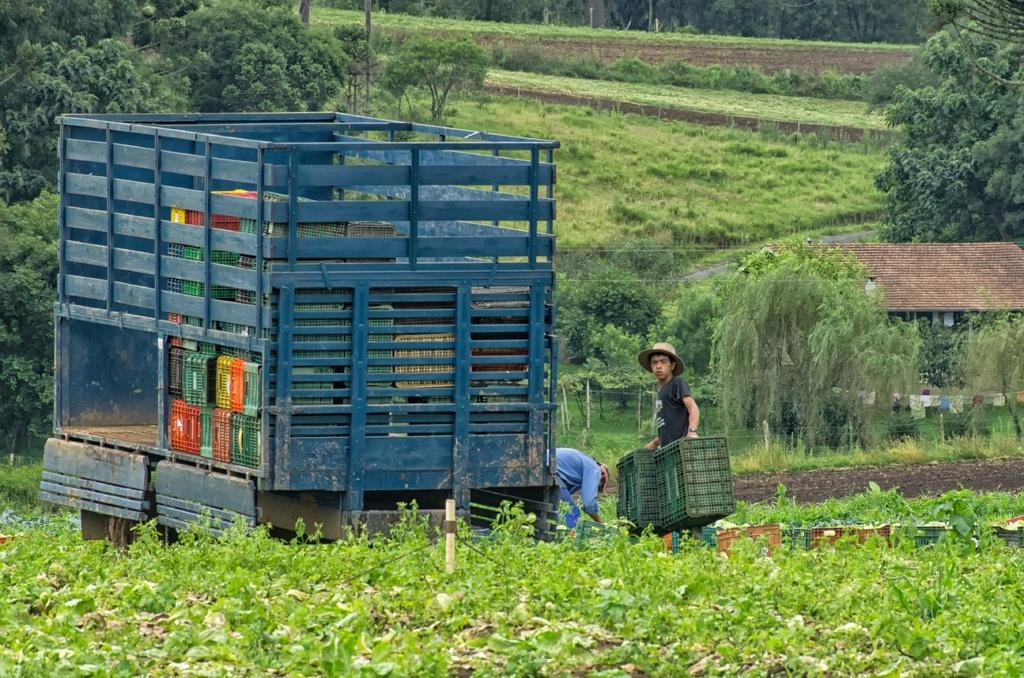What type of vehicle is in the image? There is a blue color truck in the image. Who is present near the truck? There are two members on the ground beside the truck. What can be seen in the background of the image? Plants, grass, and trees are visible in the background of the image. What invention is being showcased in the library in the image? There is no library or invention present in the image; it features a blue color truck and people on the ground. 